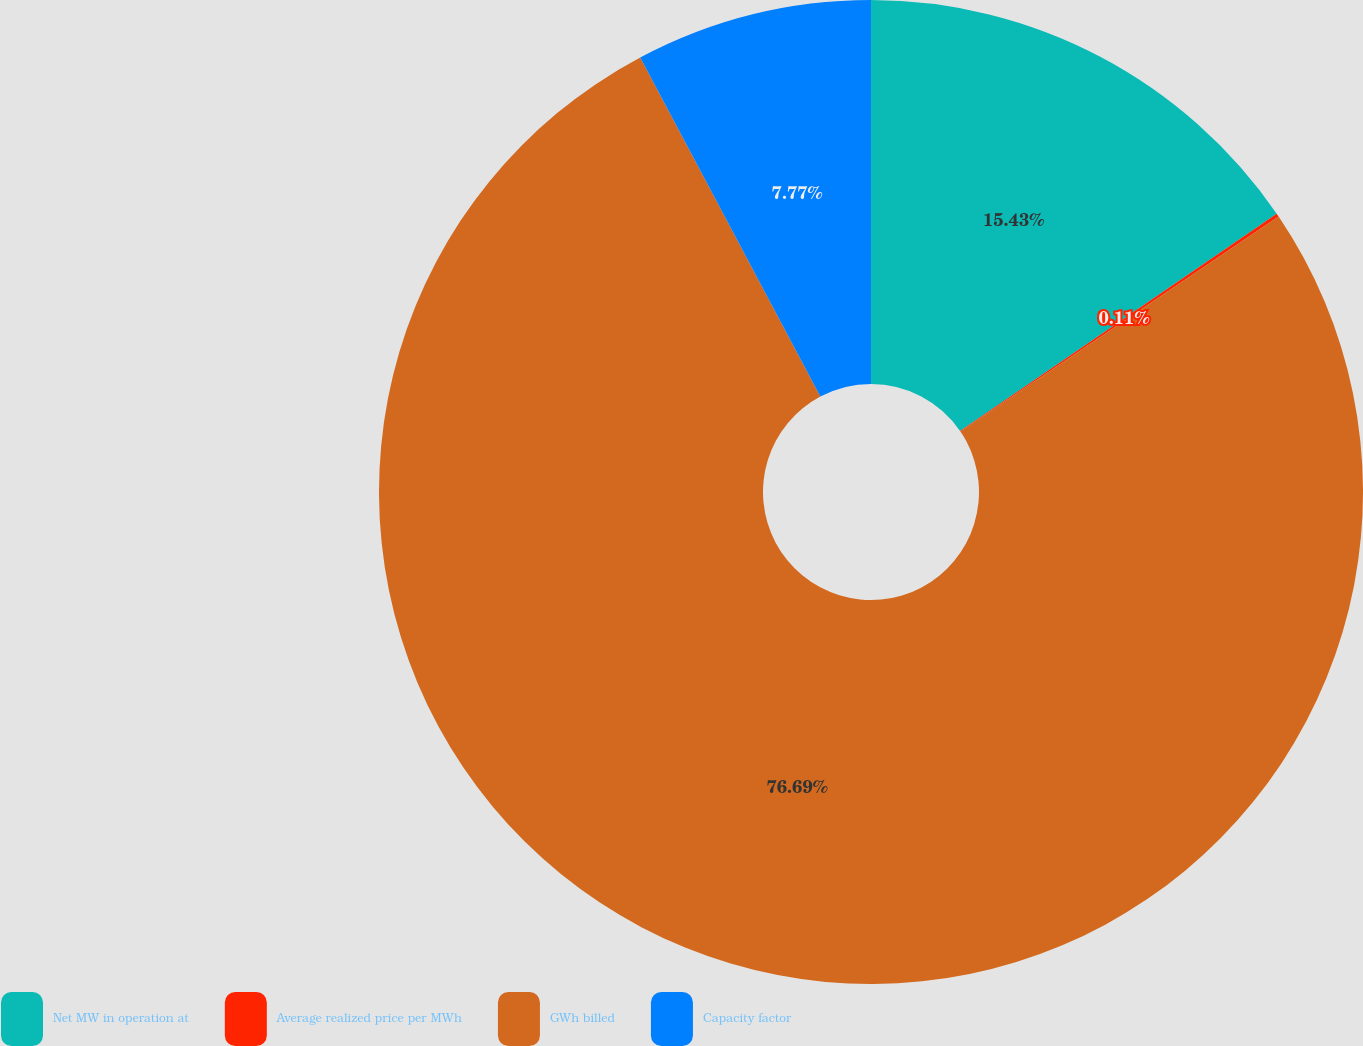Convert chart to OTSL. <chart><loc_0><loc_0><loc_500><loc_500><pie_chart><fcel>Net MW in operation at<fcel>Average realized price per MWh<fcel>GWh billed<fcel>Capacity factor<nl><fcel>15.43%<fcel>0.11%<fcel>76.69%<fcel>7.77%<nl></chart> 